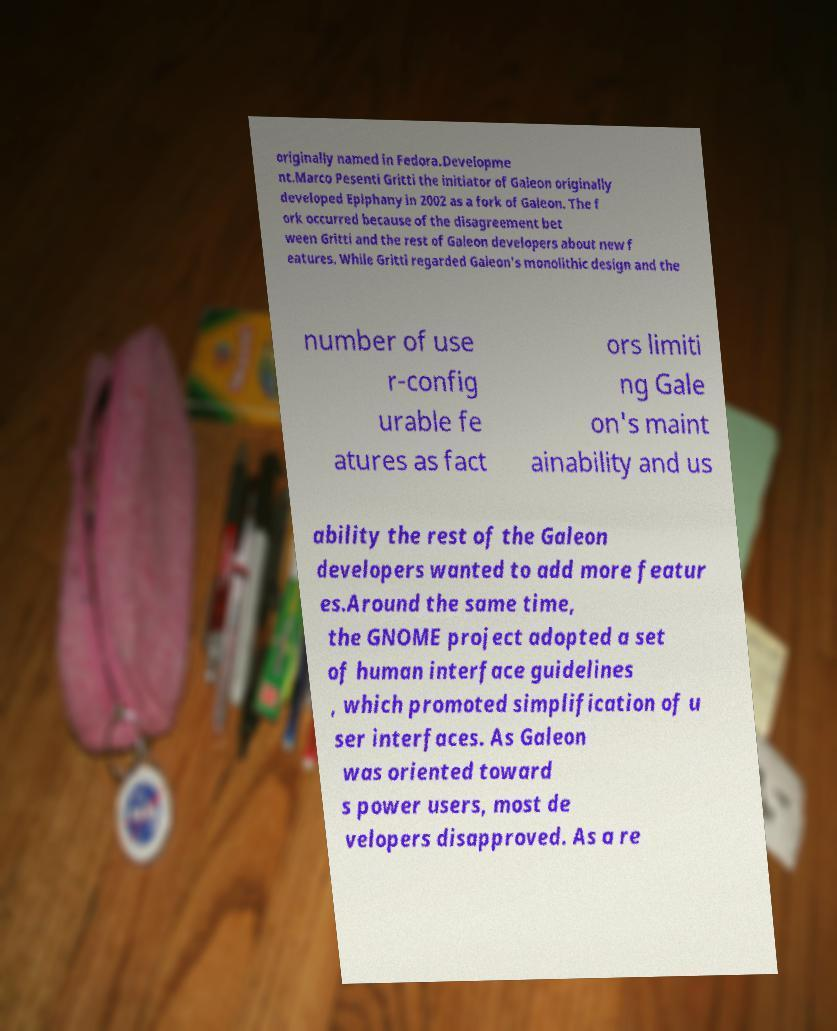Can you accurately transcribe the text from the provided image for me? originally named in Fedora.Developme nt.Marco Pesenti Gritti the initiator of Galeon originally developed Epiphany in 2002 as a fork of Galeon. The f ork occurred because of the disagreement bet ween Gritti and the rest of Galeon developers about new f eatures. While Gritti regarded Galeon's monolithic design and the number of use r-config urable fe atures as fact ors limiti ng Gale on's maint ainability and us ability the rest of the Galeon developers wanted to add more featur es.Around the same time, the GNOME project adopted a set of human interface guidelines , which promoted simplification of u ser interfaces. As Galeon was oriented toward s power users, most de velopers disapproved. As a re 